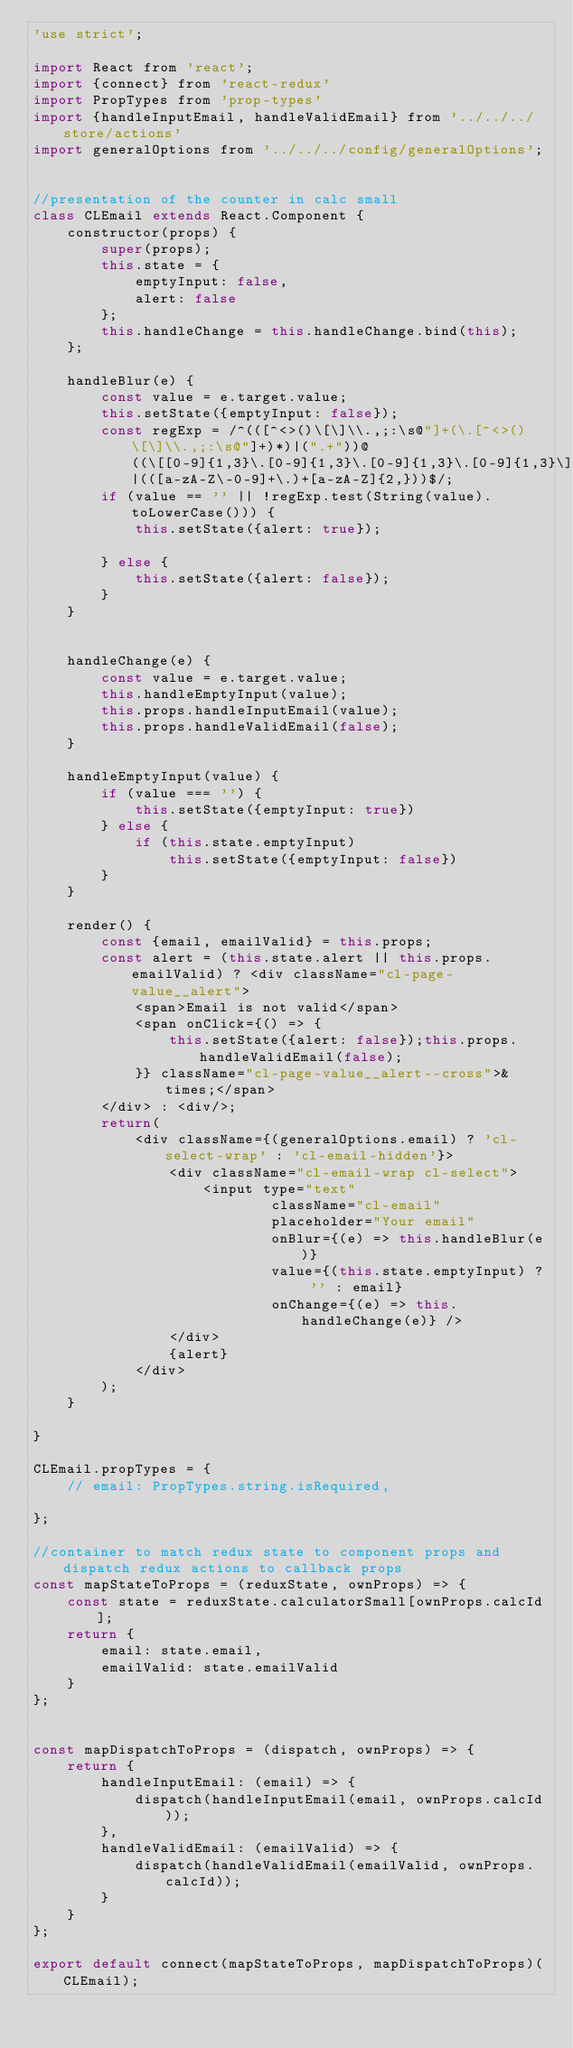Convert code to text. <code><loc_0><loc_0><loc_500><loc_500><_JavaScript_>'use strict';

import React from 'react';
import {connect} from 'react-redux'
import PropTypes from 'prop-types'
import {handleInputEmail, handleValidEmail} from '../../../store/actions'
import generalOptions from '../../../config/generalOptions';


//presentation of the counter in calc small
class CLEmail extends React.Component {
    constructor(props) {
        super(props);
        this.state = {
            emptyInput: false,
            alert: false
        };
        this.handleChange = this.handleChange.bind(this);
    };

    handleBlur(e) {
        const value = e.target.value;
        this.setState({emptyInput: false});
        const regExp = /^(([^<>()\[\]\\.,;:\s@"]+(\.[^<>()\[\]\\.,;:\s@"]+)*)|(".+"))@((\[[0-9]{1,3}\.[0-9]{1,3}\.[0-9]{1,3}\.[0-9]{1,3}\])|(([a-zA-Z\-0-9]+\.)+[a-zA-Z]{2,}))$/;
        if (value == '' || !regExp.test(String(value).toLowerCase())) {
            this.setState({alert: true});
            
        } else {
            this.setState({alert: false});
        }
    }


    handleChange(e) {
        const value = e.target.value;
        this.handleEmptyInput(value);
        this.props.handleInputEmail(value);
        this.props.handleValidEmail(false);
    }

    handleEmptyInput(value) {
        if (value === '') {
            this.setState({emptyInput: true})
        } else {
            if (this.state.emptyInput)
                this.setState({emptyInput: false})
        }
    }

    render() {
        const {email, emailValid} = this.props;
        const alert = (this.state.alert || this.props.emailValid) ? <div className="cl-page-value__alert">
            <span>Email is not valid</span>
            <span onClick={() => {
                this.setState({alert: false});this.props.handleValidEmail(false);
            }} className="cl-page-value__alert--cross">&times;</span>
        </div> : <div/>;
        return(
            <div className={(generalOptions.email) ? 'cl-select-wrap' : 'cl-email-hidden'}>
                <div className="cl-email-wrap cl-select">
                    <input type="text" 
                            className="cl-email" 
                            placeholder="Your email" 
                            onBlur={(e) => this.handleBlur(e)}
                            value={(this.state.emptyInput) ? '' : email}
                            onChange={(e) => this.handleChange(e)} />
                </div>
                {alert}
            </div>
        );
    }

}

CLEmail.propTypes = {
    // email: PropTypes.string.isRequired,

};

//container to match redux state to component props and dispatch redux actions to callback props
const mapStateToProps = (reduxState, ownProps) => {
    const state = reduxState.calculatorSmall[ownProps.calcId];
    return {
        email: state.email,
        emailValid: state.emailValid
    }
};


const mapDispatchToProps = (dispatch, ownProps) => {
    return {
        handleInputEmail: (email) => {
            dispatch(handleInputEmail(email, ownProps.calcId));
        },
        handleValidEmail: (emailValid) => {
            dispatch(handleValidEmail(emailValid, ownProps.calcId));
        }
    }
};

export default connect(mapStateToProps, mapDispatchToProps)(CLEmail);</code> 